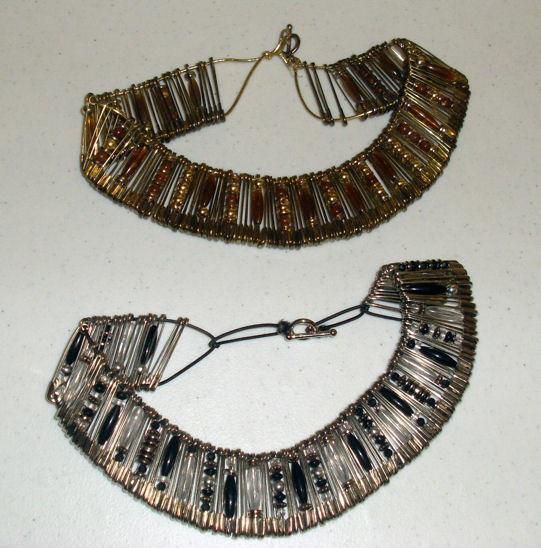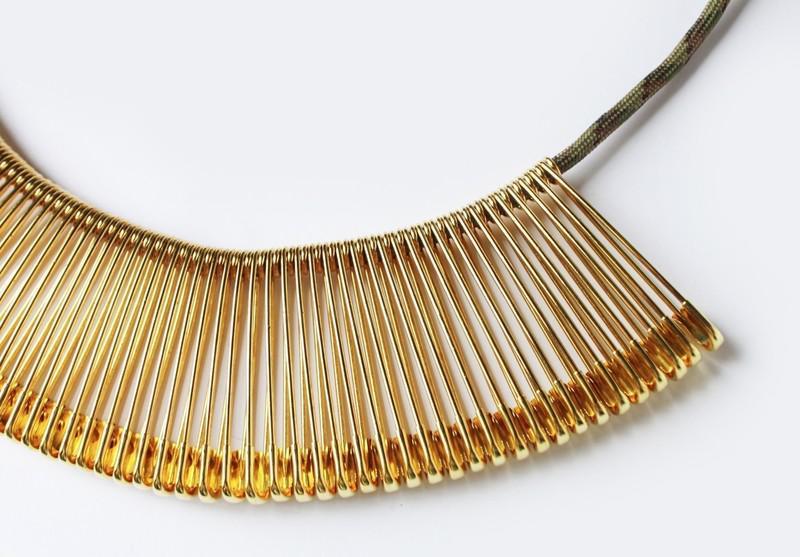The first image is the image on the left, the second image is the image on the right. Considering the images on both sides, is "The jewelry in the right photo is not made with any silver colored safety pins." valid? Answer yes or no. Yes. The first image is the image on the left, the second image is the image on the right. For the images displayed, is the sentence "An image features a necklace strung with only gold safety pins." factually correct? Answer yes or no. Yes. 